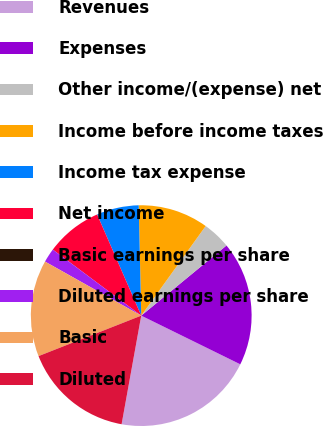Convert chart. <chart><loc_0><loc_0><loc_500><loc_500><pie_chart><fcel>Revenues<fcel>Expenses<fcel>Other income/(expense) net<fcel>Income before income taxes<fcel>Income tax expense<fcel>Net income<fcel>Basic earnings per share<fcel>Diluted earnings per share<fcel>Basic<fcel>Diluted<nl><fcel>20.58%<fcel>18.23%<fcel>4.12%<fcel>10.29%<fcel>6.18%<fcel>8.24%<fcel>0.01%<fcel>2.06%<fcel>14.12%<fcel>16.18%<nl></chart> 